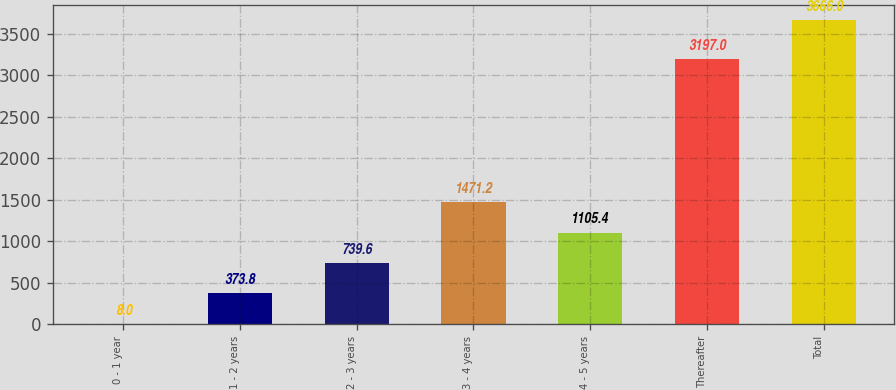Convert chart to OTSL. <chart><loc_0><loc_0><loc_500><loc_500><bar_chart><fcel>0 - 1 year<fcel>1 - 2 years<fcel>2 - 3 years<fcel>3 - 4 years<fcel>4 - 5 years<fcel>Thereafter<fcel>Total<nl><fcel>8<fcel>373.8<fcel>739.6<fcel>1471.2<fcel>1105.4<fcel>3197<fcel>3666<nl></chart> 